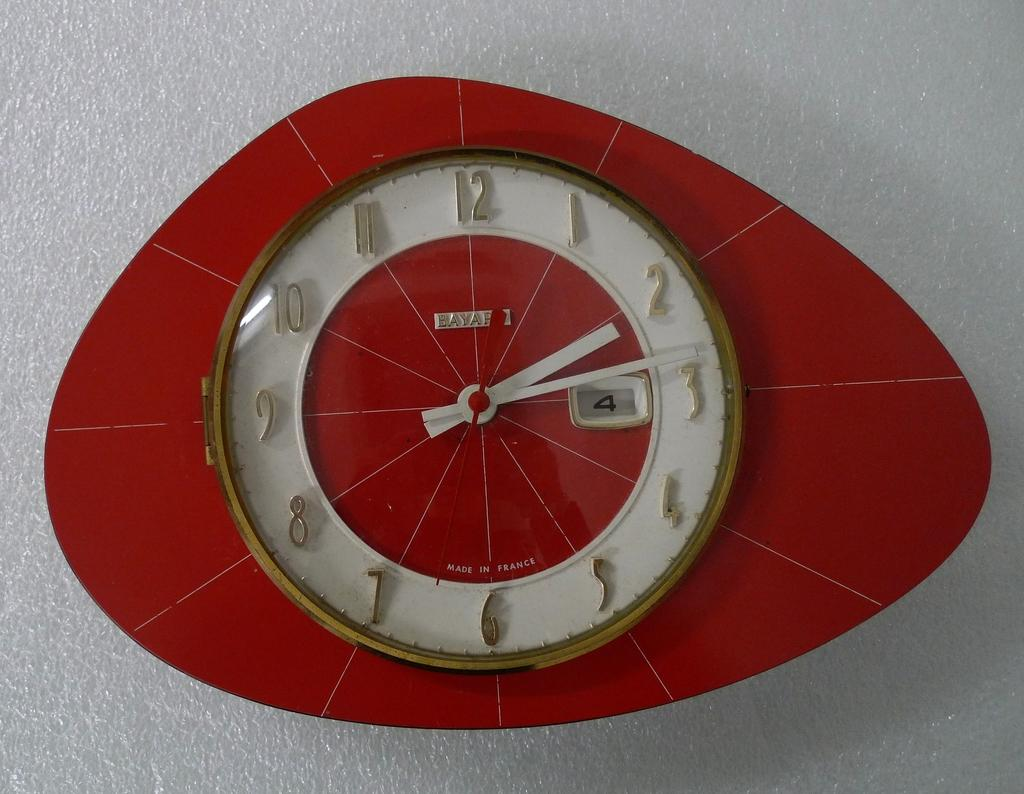<image>
Create a compact narrative representing the image presented. A interesting shaped clock, that is red and white reads 2:14. 